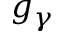Convert formula to latex. <formula><loc_0><loc_0><loc_500><loc_500>g _ { \gamma }</formula> 